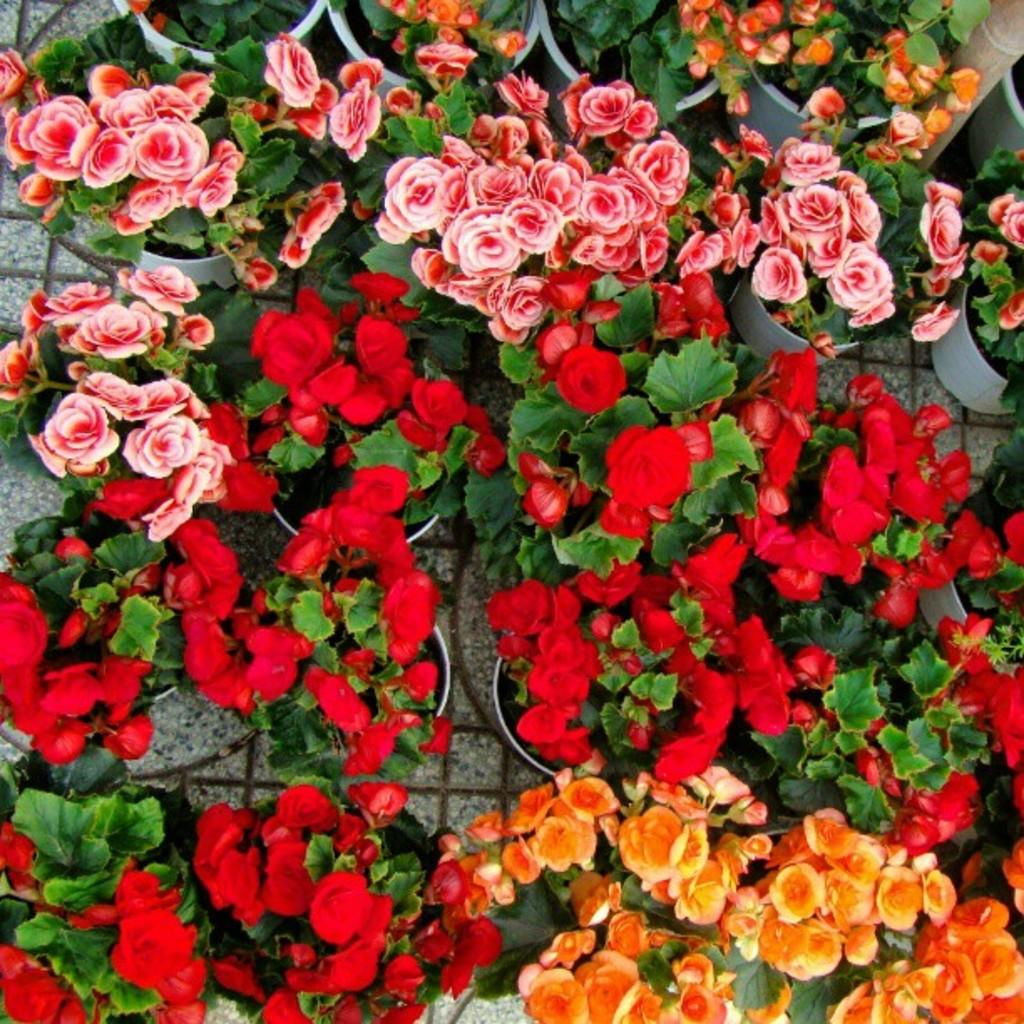What type of plants are visible in the image? There are flowers in the image. How are the flowers arranged or contained in the image? The flowers are in potted plants. What type of jeans are the chickens wearing in the image? There are no chickens or jeans present in the image; it features flowers in potted plants. Is there a scarecrow visible in the image? There is no scarecrow present in the image; it features flowers in potted plants. 